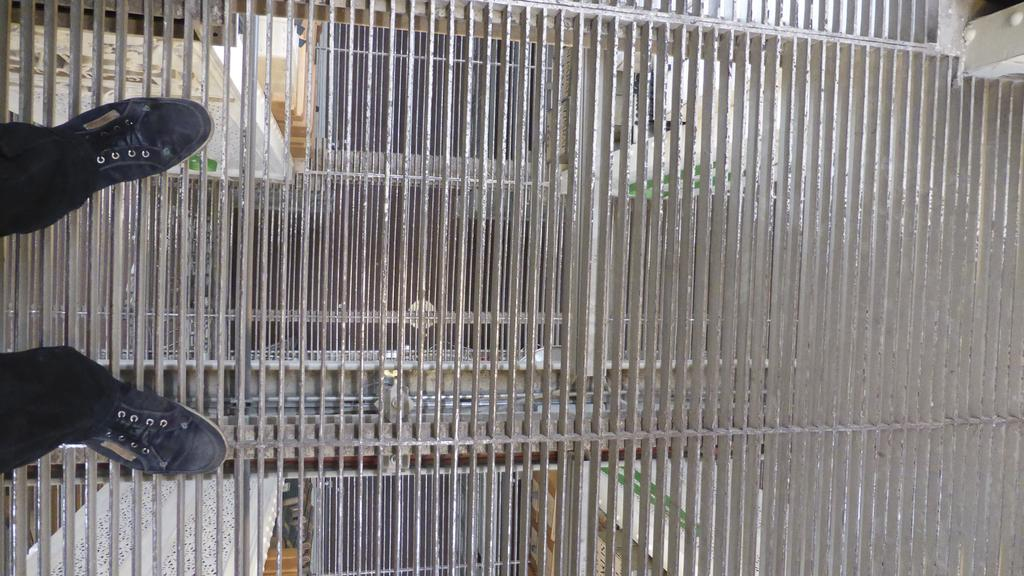Who or what is present in the image? There is a person in the image. What part of the person's body can be seen? The person's legs are visible. What type of footwear is the person wearing? The person is wearing shoes. What is the person standing on in the image? The person is standing on a metal object. What type of hall can be seen in the background of the image? There is no hall visible in the image; it only features a person standing on a metal object. 